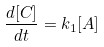Convert formula to latex. <formula><loc_0><loc_0><loc_500><loc_500>\frac { d [ C ] } { d t } = k _ { 1 } [ A ]</formula> 